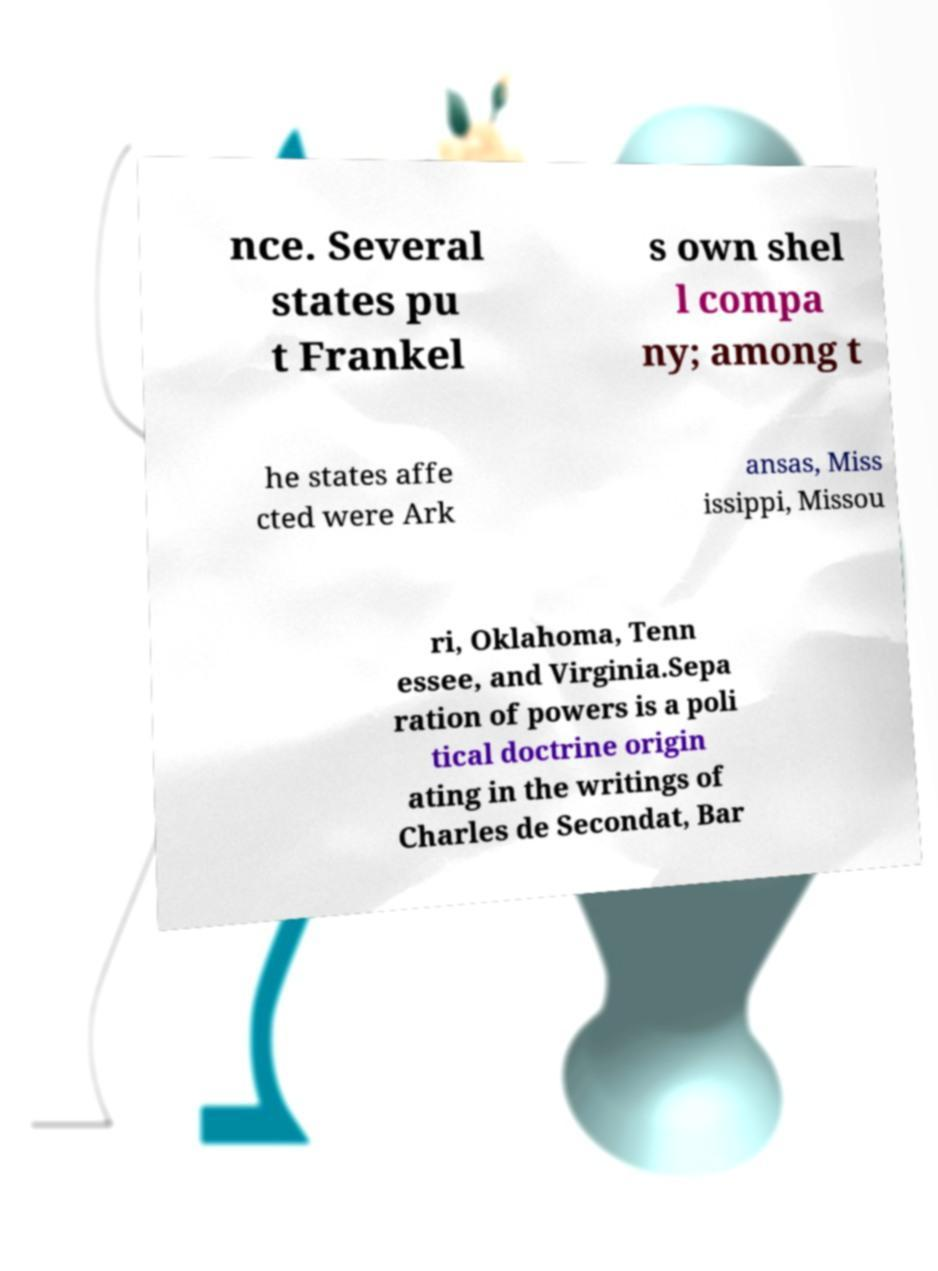I need the written content from this picture converted into text. Can you do that? nce. Several states pu t Frankel s own shel l compa ny; among t he states affe cted were Ark ansas, Miss issippi, Missou ri, Oklahoma, Tenn essee, and Virginia.Sepa ration of powers is a poli tical doctrine origin ating in the writings of Charles de Secondat, Bar 